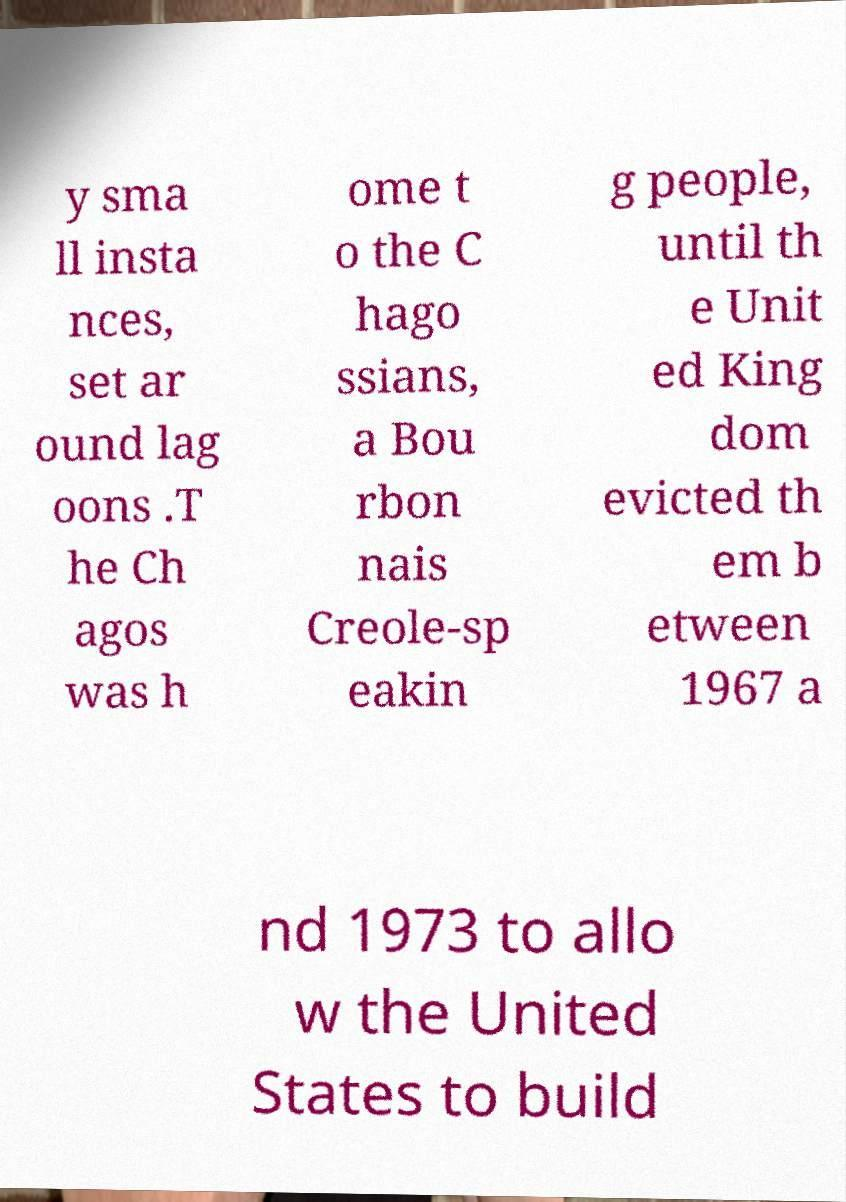Please read and relay the text visible in this image. What does it say? y sma ll insta nces, set ar ound lag oons .T he Ch agos was h ome t o the C hago ssians, a Bou rbon nais Creole-sp eakin g people, until th e Unit ed King dom evicted th em b etween 1967 a nd 1973 to allo w the United States to build 